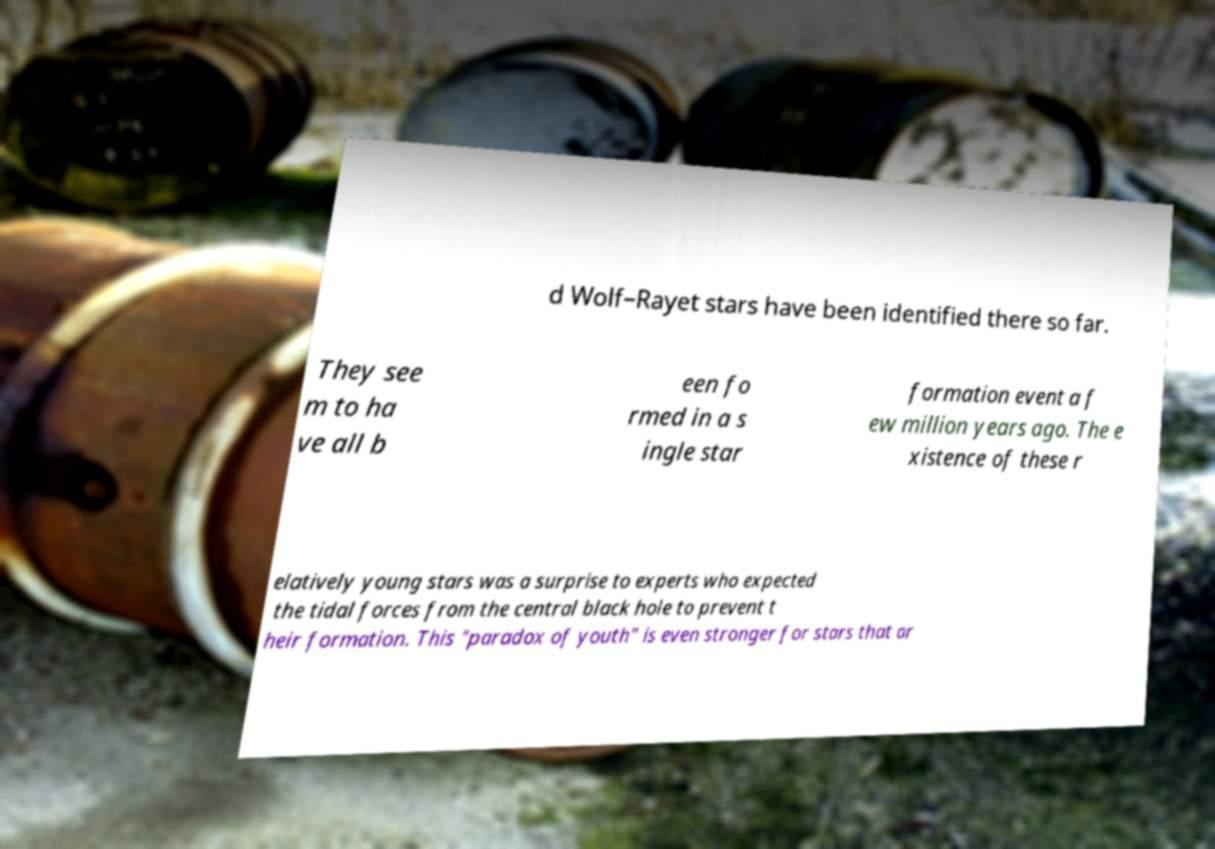Could you assist in decoding the text presented in this image and type it out clearly? d Wolf–Rayet stars have been identified there so far. They see m to ha ve all b een fo rmed in a s ingle star formation event a f ew million years ago. The e xistence of these r elatively young stars was a surprise to experts who expected the tidal forces from the central black hole to prevent t heir formation. This "paradox of youth" is even stronger for stars that ar 